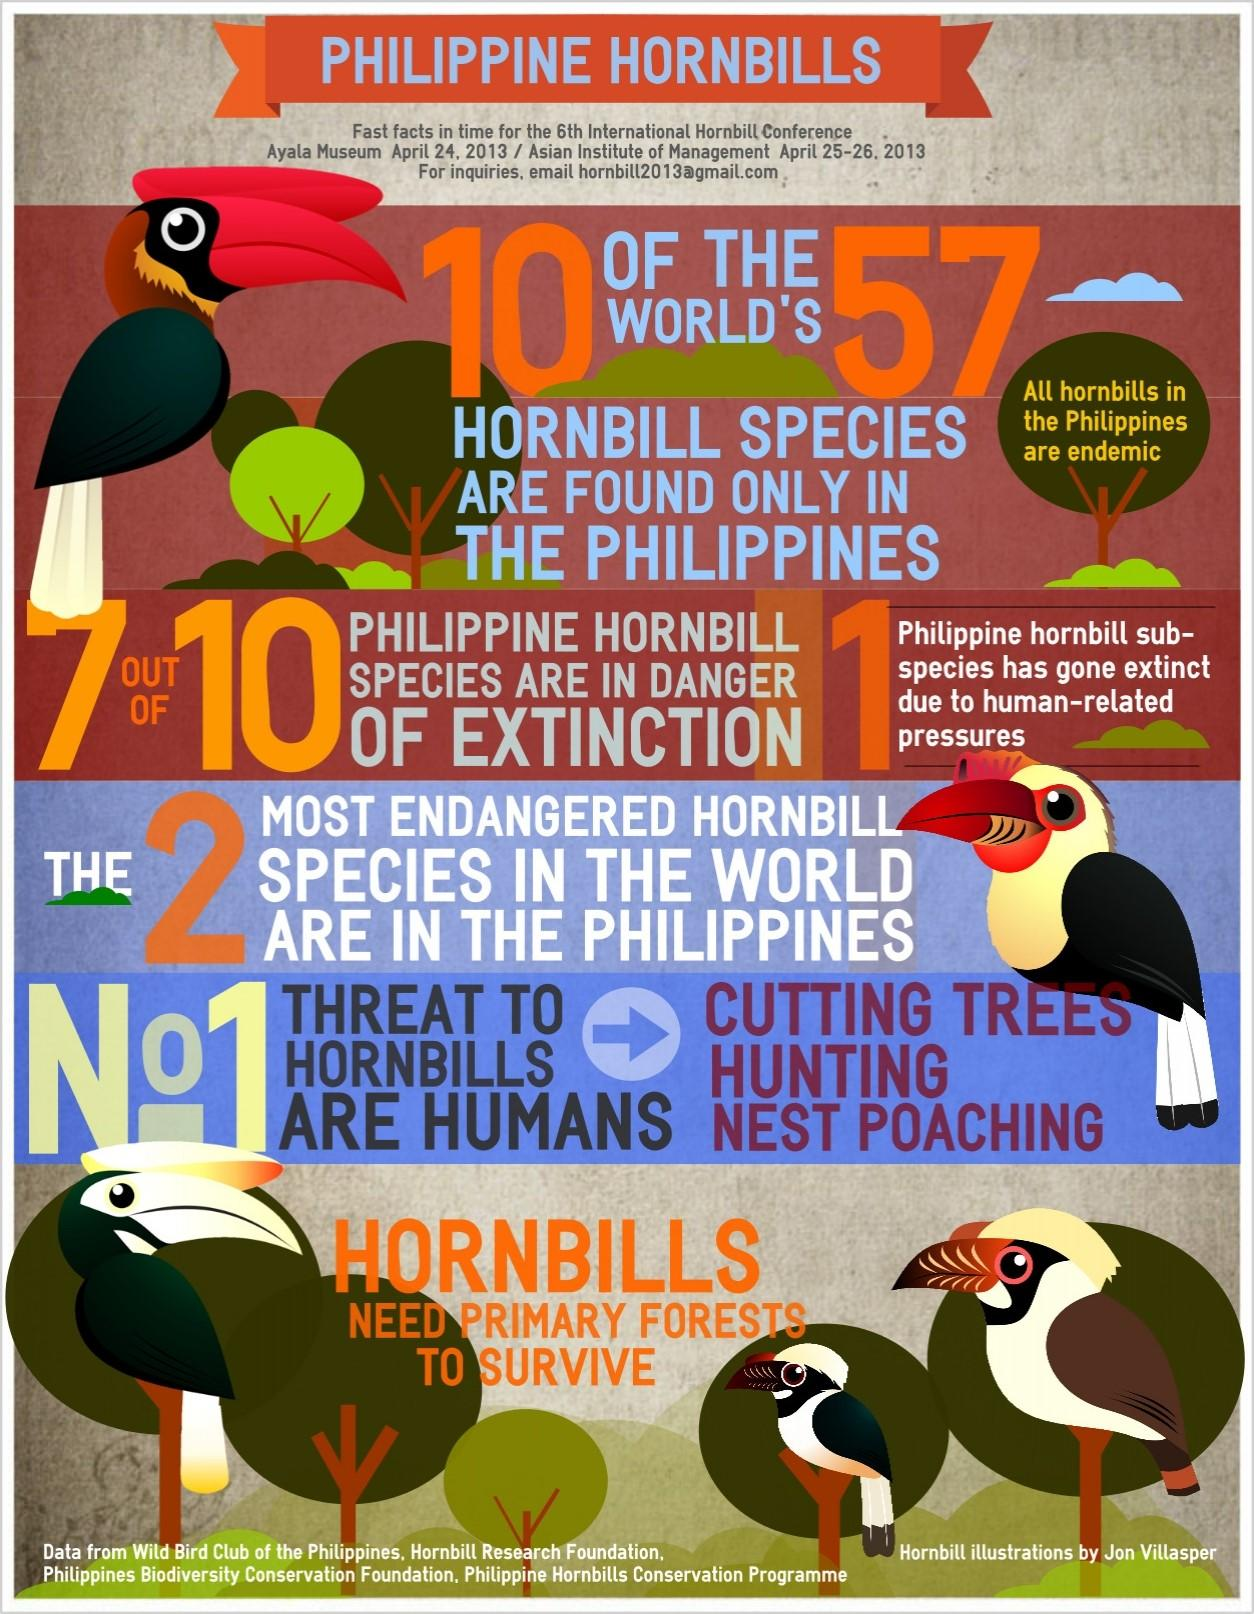Give some essential details in this illustration. Of the 10 Philippine hornbill species, three are not currently at risk of extinction. There are five hornbill images included in this infographic. Out of the total number of 57 hornbill species, only 47 have been found in the Philippines. 